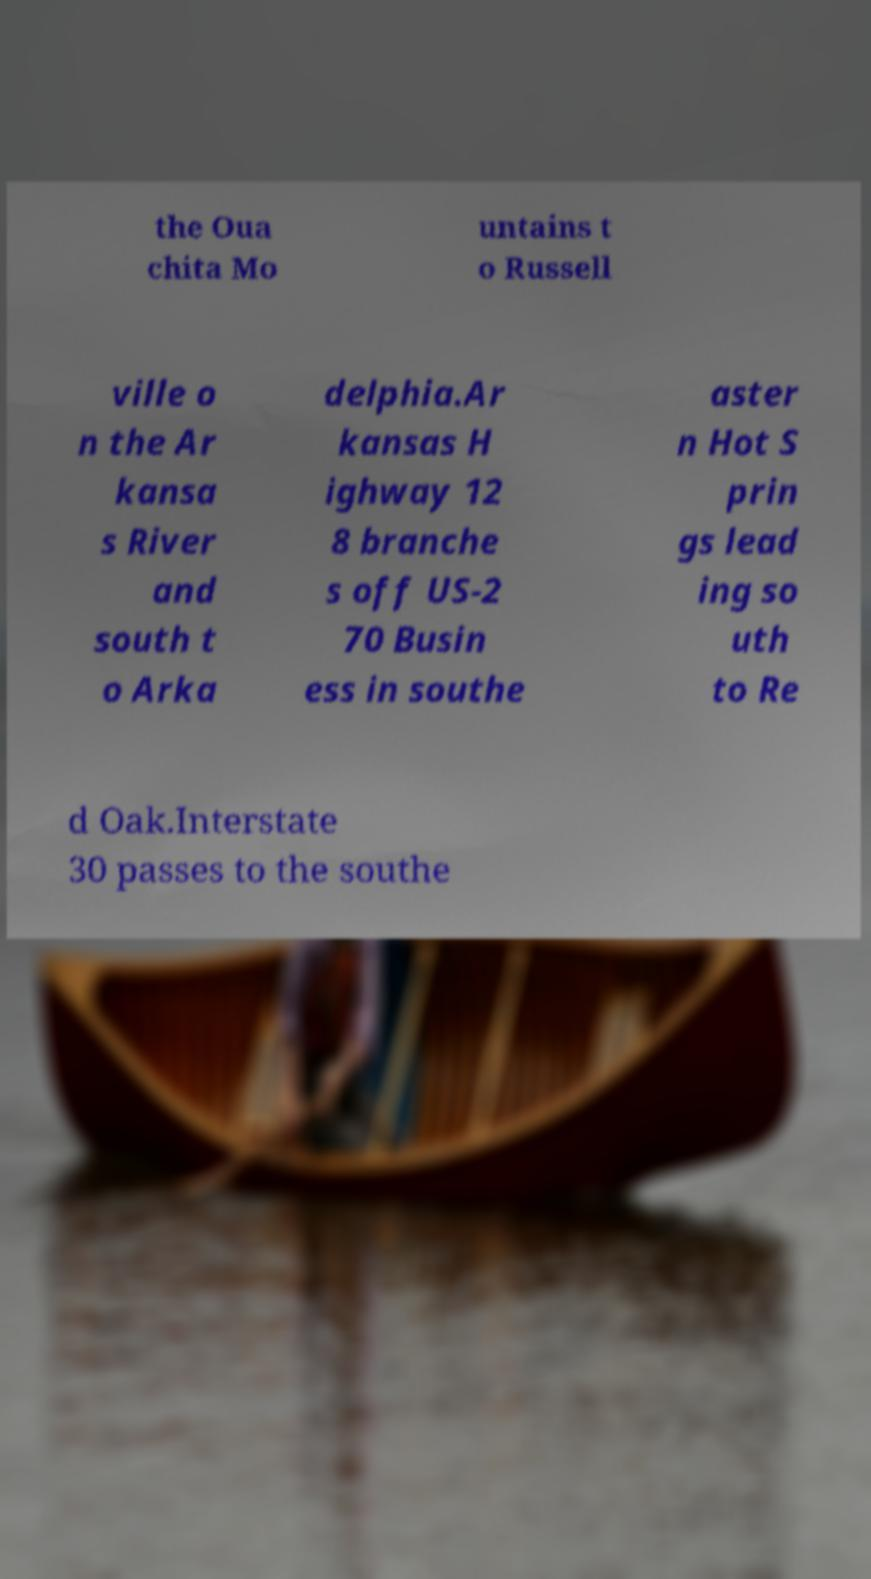For documentation purposes, I need the text within this image transcribed. Could you provide that? the Oua chita Mo untains t o Russell ville o n the Ar kansa s River and south t o Arka delphia.Ar kansas H ighway 12 8 branche s off US-2 70 Busin ess in southe aster n Hot S prin gs lead ing so uth to Re d Oak.Interstate 30 passes to the southe 